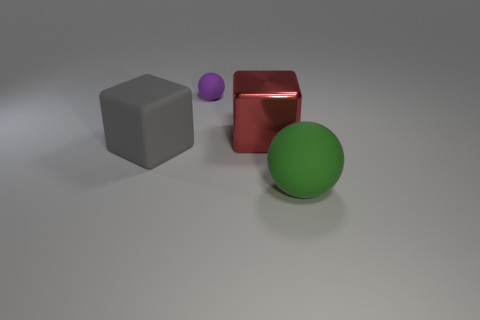Are the shapes in the image arranged in any particular pattern? The shapes in the image are not arranged in a specific pattern. They are spaced apart with no discernible arrangement, allowing each object to stand out on its own. The variation in colors and textures further emphasizes their individuality. 